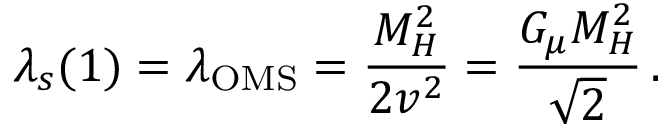<formula> <loc_0><loc_0><loc_500><loc_500>\lambda _ { s } ( 1 ) = \lambda _ { O M S } = \frac { M _ { H } ^ { 2 } } { 2 v ^ { 2 } } = \frac { G _ { \mu } M _ { H } ^ { 2 } } { \sqrt { 2 } } \, .</formula> 